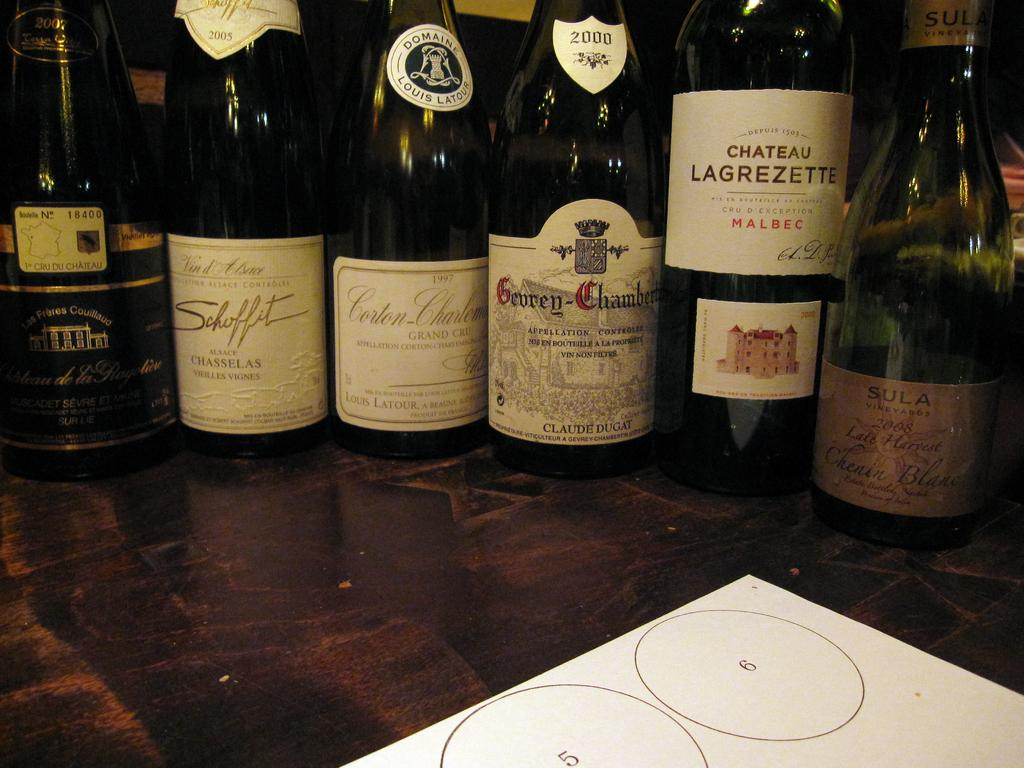<image>
Summarize the visual content of the image. A sheet of paper has the numbers 5 and 6 on it in circles. 